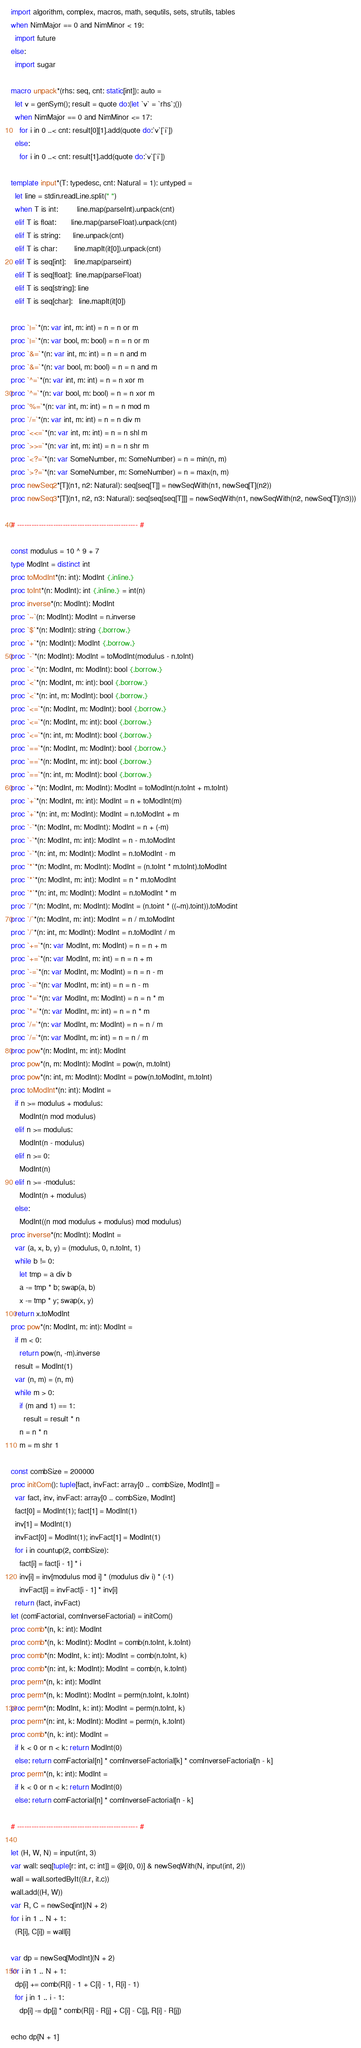Convert code to text. <code><loc_0><loc_0><loc_500><loc_500><_Nim_>import algorithm, complex, macros, math, sequtils, sets, strutils, tables
when NimMajor == 0 and NimMinor < 19:
  import future
else:
  import sugar

macro unpack*(rhs: seq, cnt: static[int]): auto =
  let v = genSym(); result = quote do:(let `v` = `rhs`;())
  when NimMajor == 0 and NimMinor <= 17:
    for i in 0 ..< cnt: result[0][1].add(quote do:`v`[`i`])
  else:
    for i in 0 ..< cnt: result[1].add(quote do:`v`[`i`])

template input*(T: typedesc, cnt: Natural = 1): untyped =
  let line = stdin.readLine.split(" ")
  when T is int:         line.map(parseInt).unpack(cnt)
  elif T is float:       line.map(parseFloat).unpack(cnt)
  elif T is string:      line.unpack(cnt)
  elif T is char:        line.mapIt(it[0]).unpack(cnt)
  elif T is seq[int]:    line.map(parseint)
  elif T is seq[float]:  line.map(parseFloat)
  elif T is seq[string]: line
  elif T is seq[char]:   line.mapIt(it[0])

proc `|=`*(n: var int, m: int) = n = n or m
proc `|=`*(n: var bool, m: bool) = n = n or m
proc `&=`*(n: var int, m: int) = n = n and m
proc `&=`*(n: var bool, m: bool) = n = n and m
proc `^=`*(n: var int, m: int) = n = n xor m
proc `^=`*(n: var bool, m: bool) = n = n xor m
proc `%=`*(n: var int, m: int) = n = n mod m
proc `/=`*(n: var int, m: int) = n = n div m
proc `<<=`*(n: var int, m: int) = n = n shl m
proc `>>=`*(n: var int, m: int) = n = n shr m
proc `<?=`*(n: var SomeNumber, m: SomeNumber) = n = min(n, m)
proc `>?=`*(n: var SomeNumber, m: SomeNumber) = n = max(n, m)
proc newSeq2*[T](n1, n2: Natural): seq[seq[T]] = newSeqWith(n1, newSeq[T](n2))
proc newSeq3*[T](n1, n2, n3: Natural): seq[seq[seq[T]]] = newSeqWith(n1, newSeqWith(n2, newSeq[T](n3)))

# -------------------------------------------------- #

const modulus = 10 ^ 9 + 7
type ModInt = distinct int
proc toModInt*(n: int): ModInt {.inline.}
proc toInt*(n: ModInt): int {.inline.} = int(n)
proc inverse*(n: ModInt): ModInt
proc `~`(n: ModInt): ModInt = n.inverse
proc `$`*(n: ModInt): string {.borrow.}
proc `+`*(n: ModInt): ModInt {.borrow.}
proc `-`*(n: ModInt): ModInt = toModInt(modulus - n.toInt)
proc `<`*(n: ModInt, m: ModInt): bool {.borrow.}
proc `<`*(n: ModInt, m: int): bool {.borrow.}
proc `<`*(n: int, m: ModInt): bool {.borrow.}
proc `<=`*(n: ModInt, m: ModInt): bool {.borrow.}
proc `<=`*(n: ModInt, m: int): bool {.borrow.}
proc `<=`*(n: int, m: ModInt): bool {.borrow.}
proc `==`*(n: ModInt, m: ModInt): bool {.borrow.}
proc `==`*(n: ModInt, m: int): bool {.borrow.}
proc `==`*(n: int, m: ModInt): bool {.borrow.}
proc `+`*(n: ModInt, m: ModInt): ModInt = toModInt(n.toInt + m.toInt)
proc `+`*(n: ModInt, m: int): ModInt = n + toModInt(m)
proc `+`*(n: int, m: ModInt): ModInt = n.toModInt + m
proc `-`*(n: ModInt, m: ModInt): ModInt = n + (-m)
proc `-`*(n: ModInt, m: int): ModInt = n - m.toModInt
proc `-`*(n: int, m: ModInt): ModInt = n.toModInt - m
proc `*`*(n: ModInt, m: ModInt): ModInt = (n.toInt * m.toInt).toModInt
proc `*`*(n: ModInt, m: int): ModInt = n * m.toModInt
proc `*`*(n: int, m: ModInt): ModInt = n.toModInt * m
proc `/`*(n: ModInt, m: ModInt): ModInt = (n.toint * ((~m).toint)).toModint
proc `/`*(n: ModInt, m: int): ModInt = n / m.toModInt
proc `/`*(n: int, m: ModInt): ModInt = n.toModInt / m
proc `+=`*(n: var ModInt, m: ModInt) = n = n + m
proc `+=`*(n: var ModInt, m: int) = n = n + m
proc `-=`*(n: var ModInt, m: ModInt) = n = n - m
proc `-=`*(n: var ModInt, m: int) = n = n - m
proc `*=`*(n: var ModInt, m: ModInt) = n = n * m
proc `*=`*(n: var ModInt, m: int) = n = n * m
proc `/=`*(n: var ModInt, m: ModInt) = n = n / m
proc `/=`*(n: var ModInt, m: int) = n = n / m
proc pow*(n: ModInt, m: int): ModInt
proc pow*(n, m: ModInt): ModInt = pow(n, m.toInt)
proc pow*(n: int, m: ModInt): ModInt = pow(n.toModInt, m.toInt)
proc toModInt*(n: int): ModInt =
  if n >= modulus + modulus:
    ModInt(n mod modulus)
  elif n >= modulus:
    ModInt(n - modulus)
  elif n >= 0:
    ModInt(n)
  elif n >= -modulus:
    ModInt(n + modulus)
  else:
    ModInt((n mod modulus + modulus) mod modulus)
proc inverse*(n: ModInt): ModInt =
  var (a, x, b, y) = (modulus, 0, n.toInt, 1)
  while b != 0:
    let tmp = a div b
    a -= tmp * b; swap(a, b)
    x -= tmp * y; swap(x, y)
  return x.toModInt
proc pow*(n: ModInt, m: int): ModInt =
  if m < 0:
    return pow(n, -m).inverse
  result = ModInt(1)
  var (n, m) = (n, m)
  while m > 0:
    if (m and 1) == 1:
      result = result * n
    n = n * n
    m = m shr 1

const combSize = 200000
proc initCom(): tuple[fact, invFact: array[0 .. combSize, ModInt]] =
  var fact, inv, invFact: array[0 .. combSize, ModInt]
  fact[0] = ModInt(1); fact[1] = ModInt(1)
  inv[1] = ModInt(1)
  invFact[0] = ModInt(1); invFact[1] = ModInt(1)
  for i in countup(2, combSize):
    fact[i] = fact[i - 1] * i
    inv[i] = inv[modulus mod i] * (modulus div i) * (-1)
    invFact[i] = invFact[i - 1] * inv[i]
  return (fact, invFact)
let (comFactorial, comInverseFactorial) = initCom()
proc comb*(n, k: int): ModInt
proc comb*(n, k: ModInt): ModInt = comb(n.toInt, k.toInt)
proc comb*(n: ModInt, k: int): ModInt = comb(n.toInt, k)
proc comb*(n: int, k: ModInt): ModInt = comb(n, k.toInt)
proc perm*(n, k: int): ModInt
proc perm*(n, k: ModInt): ModInt = perm(n.toInt, k.toInt)
proc perm*(n: ModInt, k: int): ModInt = perm(n.toInt, k)
proc perm*(n: int, k: ModInt): ModInt = perm(n, k.toInt)
proc comb*(n, k: int): ModInt =
  if k < 0 or n < k: return ModInt(0)
  else: return comFactorial[n] * comInverseFactorial[k] * comInverseFactorial[n - k]
proc perm*(n, k: int): ModInt =
  if k < 0 or n < k: return ModInt(0)
  else: return comFactorial[n] * comInverseFactorial[n - k]

# -------------------------------------------------- #

let (H, W, N) = input(int, 3)
var wall: seq[tuple[r: int, c: int]] = @[(0, 0)] & newSeqWith(N, input(int, 2))
wall = wall.sortedByIt((it.r, it.c))
wall.add((H, W))
var R, C = newSeq[int](N + 2)
for i in 1 .. N + 1:
  (R[i], C[i]) = wall[i]

var dp = newSeq[ModInt](N + 2)
for i in 1 .. N + 1:
  dp[i] += comb(R[i] - 1 + C[i] - 1, R[i] - 1)
  for j in 1 .. i - 1:
    dp[i] -= dp[j] * comb(R[i] - R[j] + C[i] - C[j], R[i] - R[j])

echo dp[N + 1]</code> 